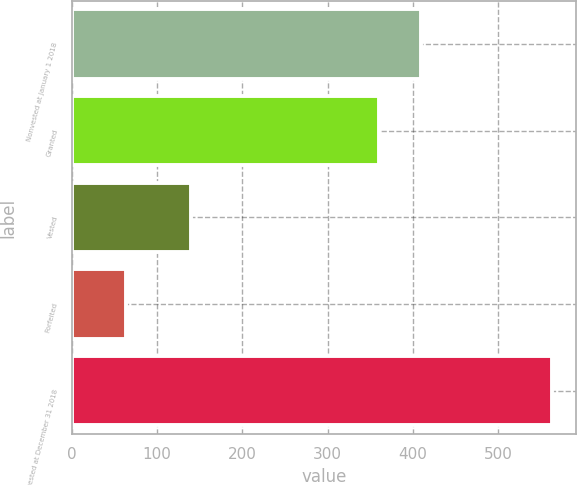Convert chart to OTSL. <chart><loc_0><loc_0><loc_500><loc_500><bar_chart><fcel>Nonvested at January 1 2018<fcel>Granted<fcel>Vested<fcel>Forfeited<fcel>Nonvested at December 31 2018<nl><fcel>410<fcel>360<fcel>140<fcel>63<fcel>563<nl></chart> 